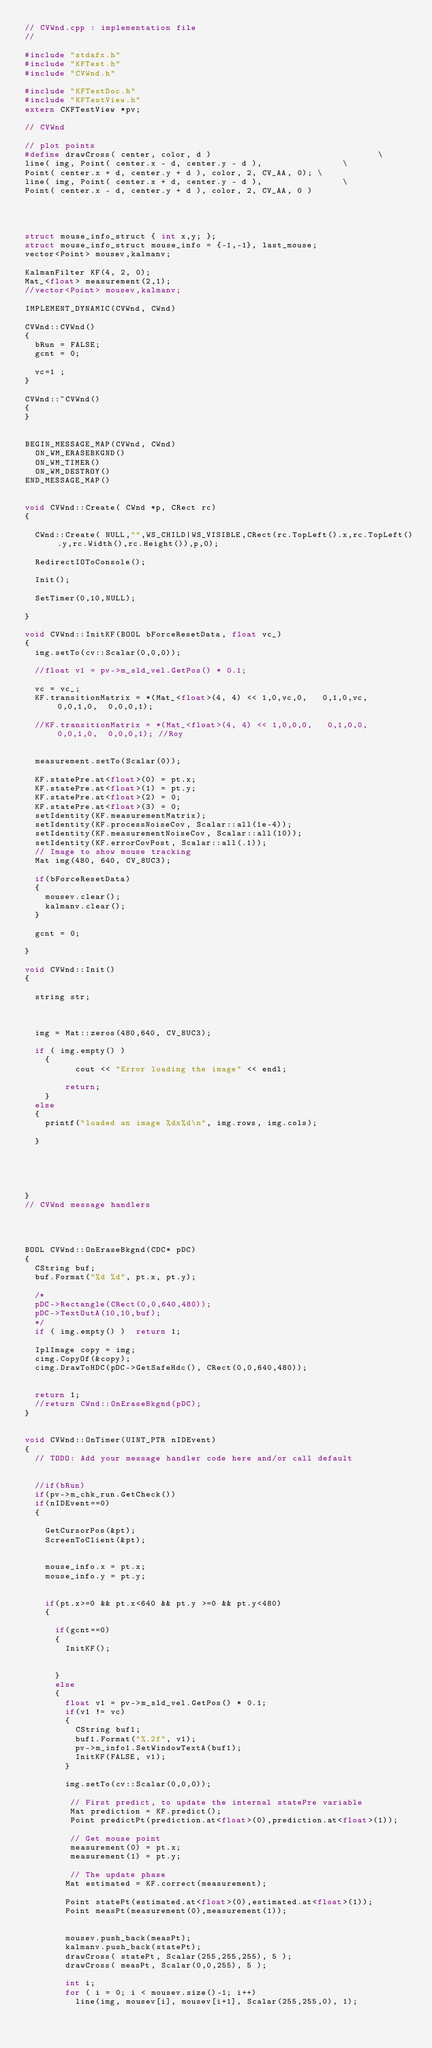<code> <loc_0><loc_0><loc_500><loc_500><_C++_>// CVWnd.cpp : implementation file
//

#include "stdafx.h"
#include "KFTest.h"
#include "CVWnd.h"

#include "KFTestDoc.h"
#include "KFTestView.h"
extern CKFTestView *pv;

// CVWnd

// plot points
#define drawCross( center, color, d )                                 \
line( img, Point( center.x - d, center.y - d ),                \
Point( center.x + d, center.y + d ), color, 2, CV_AA, 0); \
line( img, Point( center.x + d, center.y - d ),                \
Point( center.x - d, center.y + d ), color, 2, CV_AA, 0 )




struct mouse_info_struct { int x,y; };
struct mouse_info_struct mouse_info = {-1,-1}, last_mouse;
vector<Point> mousev,kalmanv;

KalmanFilter KF(4, 2, 0);
Mat_<float> measurement(2,1); 
//vector<Point> mousev,kalmanv;

IMPLEMENT_DYNAMIC(CVWnd, CWnd)

CVWnd::CVWnd()
{
	bRun = FALSE;
	gcnt = 0;

	vc=1 ;
}

CVWnd::~CVWnd()
{
}


BEGIN_MESSAGE_MAP(CVWnd, CWnd)
	ON_WM_ERASEBKGND()
	ON_WM_TIMER()
	ON_WM_DESTROY()
END_MESSAGE_MAP()


void CVWnd::Create( CWnd *p, CRect rc)
{
	
	CWnd::Create( NULL,"",WS_CHILD|WS_VISIBLE,CRect(rc.TopLeft().x,rc.TopLeft().y,rc.Width(),rc.Height()),p,0);
	
	RedirectIOToConsole();

	Init();

	SetTimer(0,10,NULL);

}

void CVWnd::InitKF(BOOL bForceResetData, float vc_)
{
	img.setTo(cv::Scalar(0,0,0));

	//float v1 = pv->m_sld_vel.GetPos() * 0.1;

	vc = vc_;
	KF.transitionMatrix = *(Mat_<float>(4, 4) << 1,0,vc,0,   0,1,0,vc,  0,0,1,0,  0,0,0,1);

	//KF.transitionMatrix = *(Mat_<float>(4, 4) << 1,0,0,0,   0,1,0,0,  0,0,1,0,  0,0,0,1);	//Roy


	measurement.setTo(Scalar(0));

	KF.statePre.at<float>(0) = pt.x;
	KF.statePre.at<float>(1) = pt.y;
	KF.statePre.at<float>(2) = 0;
	KF.statePre.at<float>(3) = 0;
	setIdentity(KF.measurementMatrix);
	setIdentity(KF.processNoiseCov, Scalar::all(1e-4));
	setIdentity(KF.measurementNoiseCov, Scalar::all(10));
	setIdentity(KF.errorCovPost, Scalar::all(.1));
	// Image to show mouse tracking
	Mat img(480, 640, CV_8UC3);
				
	if(bForceResetData)
	{
		mousev.clear();
		kalmanv.clear();
	}

	gcnt = 0;

}

void CVWnd::Init()
{

	string str;
	
	

	img = Mat::zeros(480,640, CV_8UC3);

	if ( img.empty() ) 
    { 
	        cout << "Error loading the image" << endl;

        return;
    }
	else
	{
		printf("loaded an image %dx%d\n", img.rows, img.cols);

	}


	


}
// CVWnd message handlers




BOOL CVWnd::OnEraseBkgnd(CDC* pDC)
{
	CString buf;
	buf.Format("%d %d", pt.x, pt.y);

	/*
	pDC->Rectangle(CRect(0,0,640,480));
	pDC->TextOutA(10,10,buf);
	*/
	if ( img.empty() )  return 1;

	IplImage copy = img;
	cimg.CopyOf(&copy);
	cimg.DrawToHDC(pDC->GetSafeHdc(), CRect(0,0,640,480));


	return 1;
	//return CWnd::OnEraseBkgnd(pDC);
}


void CVWnd::OnTimer(UINT_PTR nIDEvent)
{
	// TODO: Add your message handler code here and/or call default


	//if(bRun)
	if(pv->m_chk_run.GetCheck())
	if(nIDEvent==0)
	{

		GetCursorPos(&pt);
		ScreenToClient(&pt);


		mouse_info.x = pt.x;
		mouse_info.y = pt.y;


		if(pt.x>=0 && pt.x<640 && pt.y >=0 && pt.y<480)
		{

			if(gcnt==0)
			{
				InitKF();


			}
			else
			{
				float v1 = pv->m_sld_vel.GetPos() * 0.1;
				if(v1 != vc)
				{
					CString buf1; 
					buf1.Format("%.2f", v1);
					pv->m_info1.SetWindowTextA(buf1);
					InitKF(FALSE, v1);
				}

				img.setTo(cv::Scalar(0,0,0));

				 // First predict, to update the internal statePre variable
				 Mat prediction = KF.predict();
				 Point predictPt(prediction.at<float>(0),prediction.at<float>(1));
              
				 // Get mouse point
				 measurement(0) = pt.x;
				 measurement(1) = pt.y; 

				 // The update phase 
				Mat estimated = KF.correct(measurement);

				Point statePt(estimated.at<float>(0),estimated.at<float>(1));
				Point measPt(measurement(0),measurement(1));


				mousev.push_back(measPt);
				kalmanv.push_back(statePt);
				drawCross( statePt, Scalar(255,255,255), 5 );
				drawCross( measPt, Scalar(0,0,255), 5 );

				int i;
				for ( i = 0; i < mousev.size()-1; i++) 
					line(img, mousev[i], mousev[i+1], Scalar(255,255,0), 1);
     </code> 